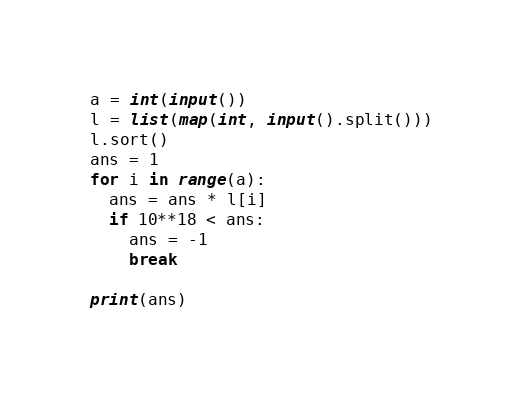Convert code to text. <code><loc_0><loc_0><loc_500><loc_500><_Python_>a = int(input())
l = list(map(int, input().split()))
l.sort()
ans = 1
for i in range(a):
  ans = ans * l[i]
  if 10**18 < ans:
    ans = -1
    break

print(ans)</code> 